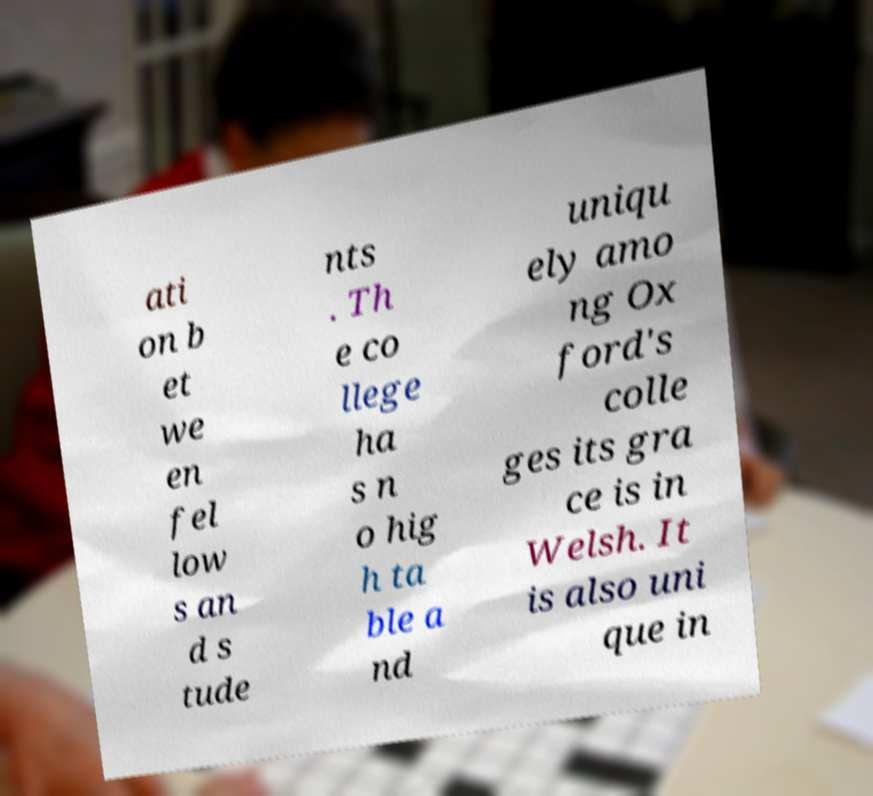Can you read and provide the text displayed in the image?This photo seems to have some interesting text. Can you extract and type it out for me? ati on b et we en fel low s an d s tude nts . Th e co llege ha s n o hig h ta ble a nd uniqu ely amo ng Ox ford's colle ges its gra ce is in Welsh. It is also uni que in 